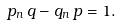Convert formula to latex. <formula><loc_0><loc_0><loc_500><loc_500>p _ { n } \, q - q _ { n } \, p = 1 .</formula> 